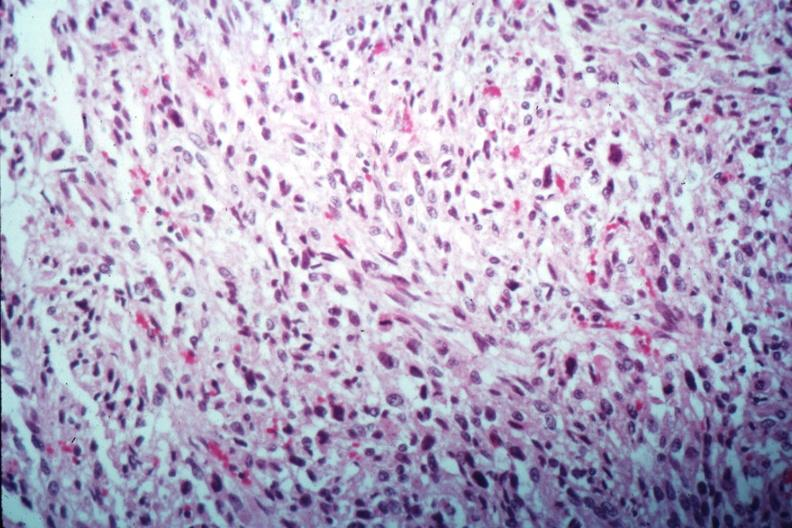s metastatic carcinoma prostate present?
Answer the question using a single word or phrase. No 